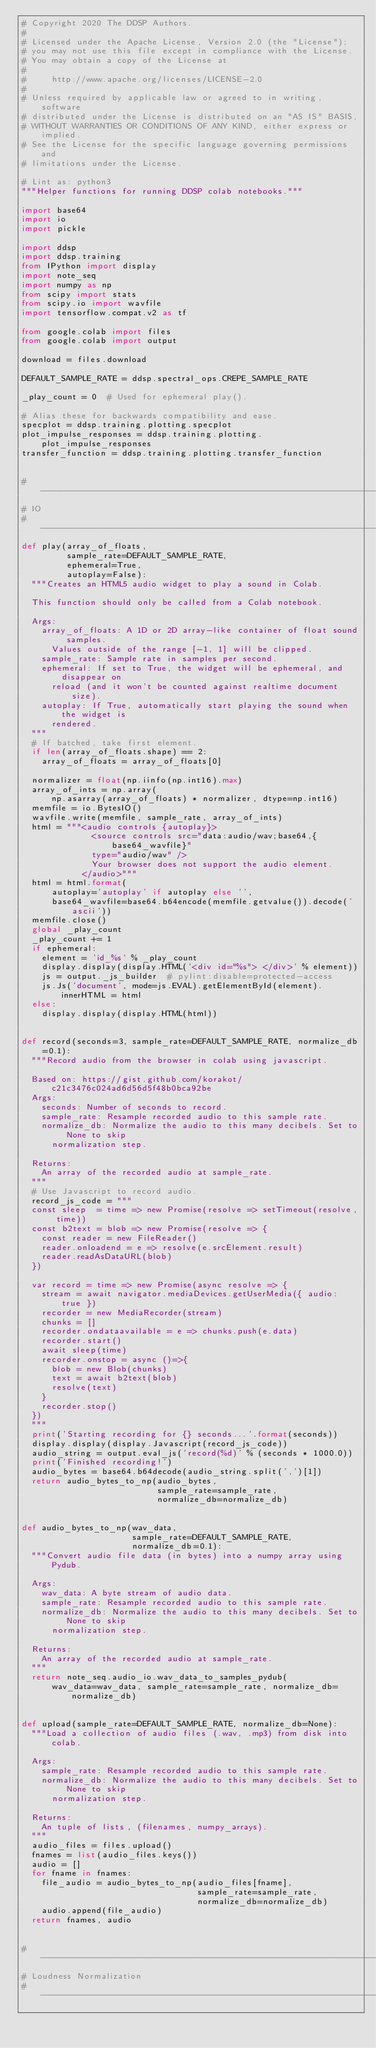<code> <loc_0><loc_0><loc_500><loc_500><_Python_># Copyright 2020 The DDSP Authors.
#
# Licensed under the Apache License, Version 2.0 (the "License");
# you may not use this file except in compliance with the License.
# You may obtain a copy of the License at
#
#     http://www.apache.org/licenses/LICENSE-2.0
#
# Unless required by applicable law or agreed to in writing, software
# distributed under the License is distributed on an "AS IS" BASIS,
# WITHOUT WARRANTIES OR CONDITIONS OF ANY KIND, either express or implied.
# See the License for the specific language governing permissions and
# limitations under the License.

# Lint as: python3
"""Helper functions for running DDSP colab notebooks."""

import base64
import io
import pickle

import ddsp
import ddsp.training
from IPython import display
import note_seq
import numpy as np
from scipy import stats
from scipy.io import wavfile
import tensorflow.compat.v2 as tf

from google.colab import files
from google.colab import output

download = files.download

DEFAULT_SAMPLE_RATE = ddsp.spectral_ops.CREPE_SAMPLE_RATE

_play_count = 0  # Used for ephemeral play().

# Alias these for backwards compatibility and ease.
specplot = ddsp.training.plotting.specplot
plot_impulse_responses = ddsp.training.plotting.plot_impulse_responses
transfer_function = ddsp.training.plotting.transfer_function


# ------------------------------------------------------------------------------
# IO
# ------------------------------------------------------------------------------
def play(array_of_floats,
         sample_rate=DEFAULT_SAMPLE_RATE,
         ephemeral=True,
         autoplay=False):
  """Creates an HTML5 audio widget to play a sound in Colab.

  This function should only be called from a Colab notebook.

  Args:
    array_of_floats: A 1D or 2D array-like container of float sound samples.
      Values outside of the range [-1, 1] will be clipped.
    sample_rate: Sample rate in samples per second.
    ephemeral: If set to True, the widget will be ephemeral, and disappear on
      reload (and it won't be counted against realtime document size).
    autoplay: If True, automatically start playing the sound when the widget is
      rendered.
  """
  # If batched, take first element.
  if len(array_of_floats.shape) == 2:
    array_of_floats = array_of_floats[0]

  normalizer = float(np.iinfo(np.int16).max)
  array_of_ints = np.array(
      np.asarray(array_of_floats) * normalizer, dtype=np.int16)
  memfile = io.BytesIO()
  wavfile.write(memfile, sample_rate, array_of_ints)
  html = """<audio controls {autoplay}>
              <source controls src="data:audio/wav;base64,{base64_wavfile}"
              type="audio/wav" />
              Your browser does not support the audio element.
            </audio>"""
  html = html.format(
      autoplay='autoplay' if autoplay else '',
      base64_wavfile=base64.b64encode(memfile.getvalue()).decode('ascii'))
  memfile.close()
  global _play_count
  _play_count += 1
  if ephemeral:
    element = 'id_%s' % _play_count
    display.display(display.HTML('<div id="%s"> </div>' % element))
    js = output._js_builder  # pylint:disable=protected-access
    js.Js('document', mode=js.EVAL).getElementById(element).innerHTML = html
  else:
    display.display(display.HTML(html))


def record(seconds=3, sample_rate=DEFAULT_SAMPLE_RATE, normalize_db=0.1):
  """Record audio from the browser in colab using javascript.

  Based on: https://gist.github.com/korakot/c21c3476c024ad6d56d5f48b0bca92be
  Args:
    seconds: Number of seconds to record.
    sample_rate: Resample recorded audio to this sample rate.
    normalize_db: Normalize the audio to this many decibels. Set to None to skip
      normalization step.

  Returns:
    An array of the recorded audio at sample_rate.
  """
  # Use Javascript to record audio.
  record_js_code = """
  const sleep  = time => new Promise(resolve => setTimeout(resolve, time))
  const b2text = blob => new Promise(resolve => {
    const reader = new FileReader()
    reader.onloadend = e => resolve(e.srcElement.result)
    reader.readAsDataURL(blob)
  })

  var record = time => new Promise(async resolve => {
    stream = await navigator.mediaDevices.getUserMedia({ audio: true })
    recorder = new MediaRecorder(stream)
    chunks = []
    recorder.ondataavailable = e => chunks.push(e.data)
    recorder.start()
    await sleep(time)
    recorder.onstop = async ()=>{
      blob = new Blob(chunks)
      text = await b2text(blob)
      resolve(text)
    }
    recorder.stop()
  })
  """
  print('Starting recording for {} seconds...'.format(seconds))
  display.display(display.Javascript(record_js_code))
  audio_string = output.eval_js('record(%d)' % (seconds * 1000.0))
  print('Finished recording!')
  audio_bytes = base64.b64decode(audio_string.split(',')[1])
  return audio_bytes_to_np(audio_bytes,
                           sample_rate=sample_rate,
                           normalize_db=normalize_db)


def audio_bytes_to_np(wav_data,
                      sample_rate=DEFAULT_SAMPLE_RATE,
                      normalize_db=0.1):
  """Convert audio file data (in bytes) into a numpy array using Pydub.

  Args:
    wav_data: A byte stream of audio data.
    sample_rate: Resample recorded audio to this sample rate.
    normalize_db: Normalize the audio to this many decibels. Set to None to skip
      normalization step.

  Returns:
    An array of the recorded audio at sample_rate.
  """
  return note_seq.audio_io.wav_data_to_samples_pydub(
      wav_data=wav_data, sample_rate=sample_rate, normalize_db=normalize_db)


def upload(sample_rate=DEFAULT_SAMPLE_RATE, normalize_db=None):
  """Load a collection of audio files (.wav, .mp3) from disk into colab.

  Args:
    sample_rate: Resample recorded audio to this sample rate.
    normalize_db: Normalize the audio to this many decibels. Set to None to skip
      normalization step.

  Returns:
    An tuple of lists, (filenames, numpy_arrays).
  """
  audio_files = files.upload()
  fnames = list(audio_files.keys())
  audio = []
  for fname in fnames:
    file_audio = audio_bytes_to_np(audio_files[fname],
                                   sample_rate=sample_rate,
                                   normalize_db=normalize_db)
    audio.append(file_audio)
  return fnames, audio


# ------------------------------------------------------------------------------
# Loudness Normalization
# ------------------------------------------------------------------------------</code> 